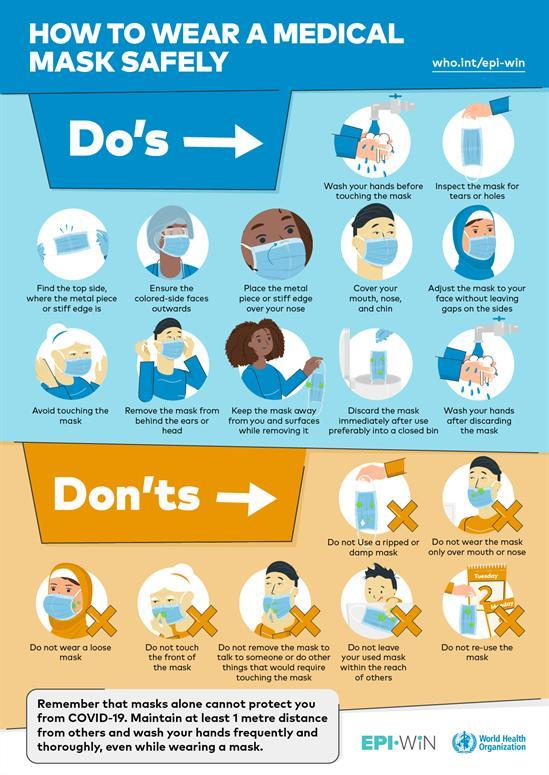How many do's are shown in this infographic image?
Answer the question with a short phrase. 12 How many don'ts are shown in this infographic image? 7 